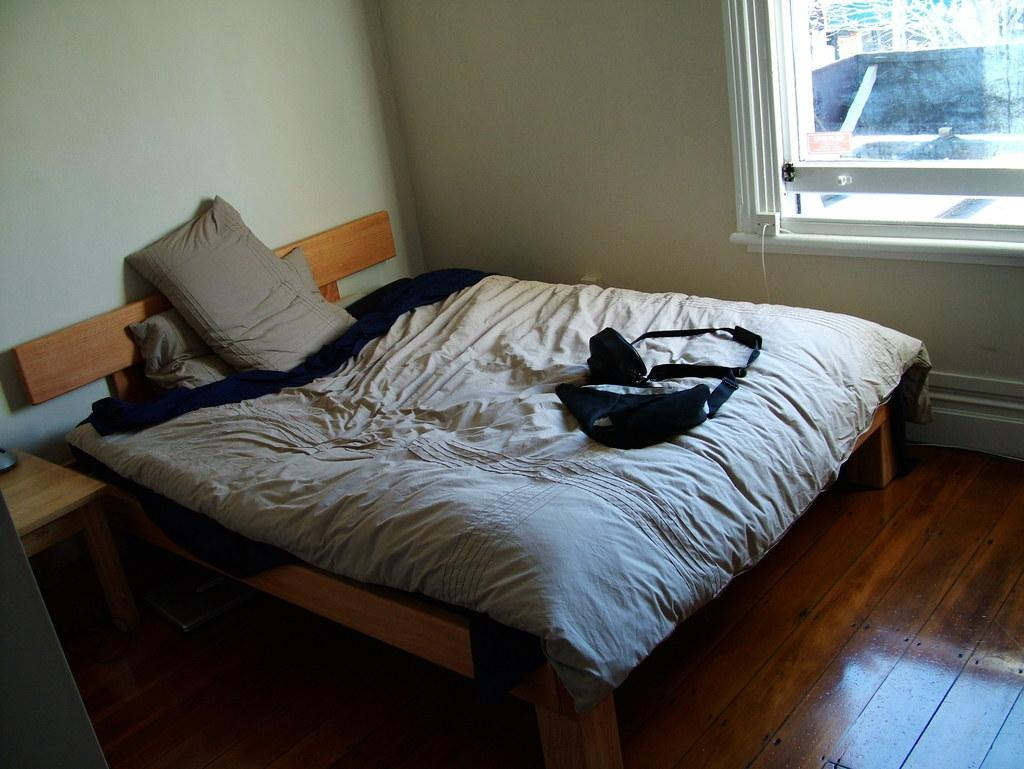What piece of furniture is present in the image? There is a bed in the image. Is there any natural light source visible in the image? Yes, there is a window to the right of the bed in the image. What type of whistle can be heard coming from the company in the image? There is no company or whistle present in the image, so it's not possible to determine what, if any, whistle might be heard. 